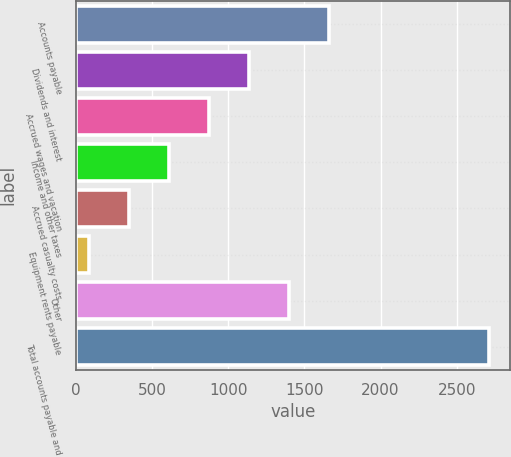Convert chart. <chart><loc_0><loc_0><loc_500><loc_500><bar_chart><fcel>Accounts payable<fcel>Dividends and interest<fcel>Accrued wages and vacation<fcel>Income and other taxes<fcel>Accrued casualty costs<fcel>Equipment rents payable<fcel>Other<fcel>Total accounts payable and<nl><fcel>1662.2<fcel>1136.8<fcel>874.1<fcel>611.4<fcel>348.7<fcel>86<fcel>1399.5<fcel>2713<nl></chart> 